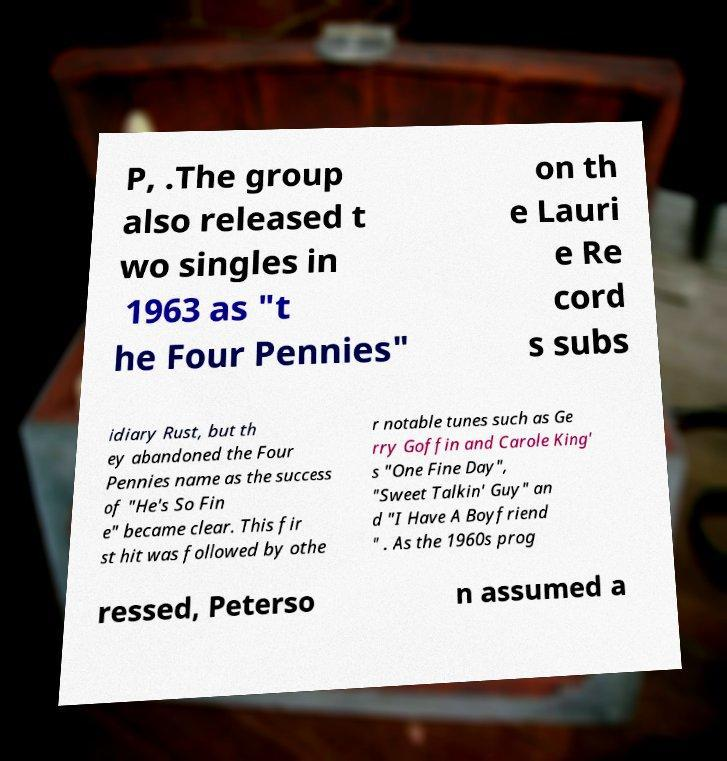Can you accurately transcribe the text from the provided image for me? P, .The group also released t wo singles in 1963 as "t he Four Pennies" on th e Lauri e Re cord s subs idiary Rust, but th ey abandoned the Four Pennies name as the success of "He's So Fin e" became clear. This fir st hit was followed by othe r notable tunes such as Ge rry Goffin and Carole King' s "One Fine Day", "Sweet Talkin' Guy" an d "I Have A Boyfriend " . As the 1960s prog ressed, Peterso n assumed a 